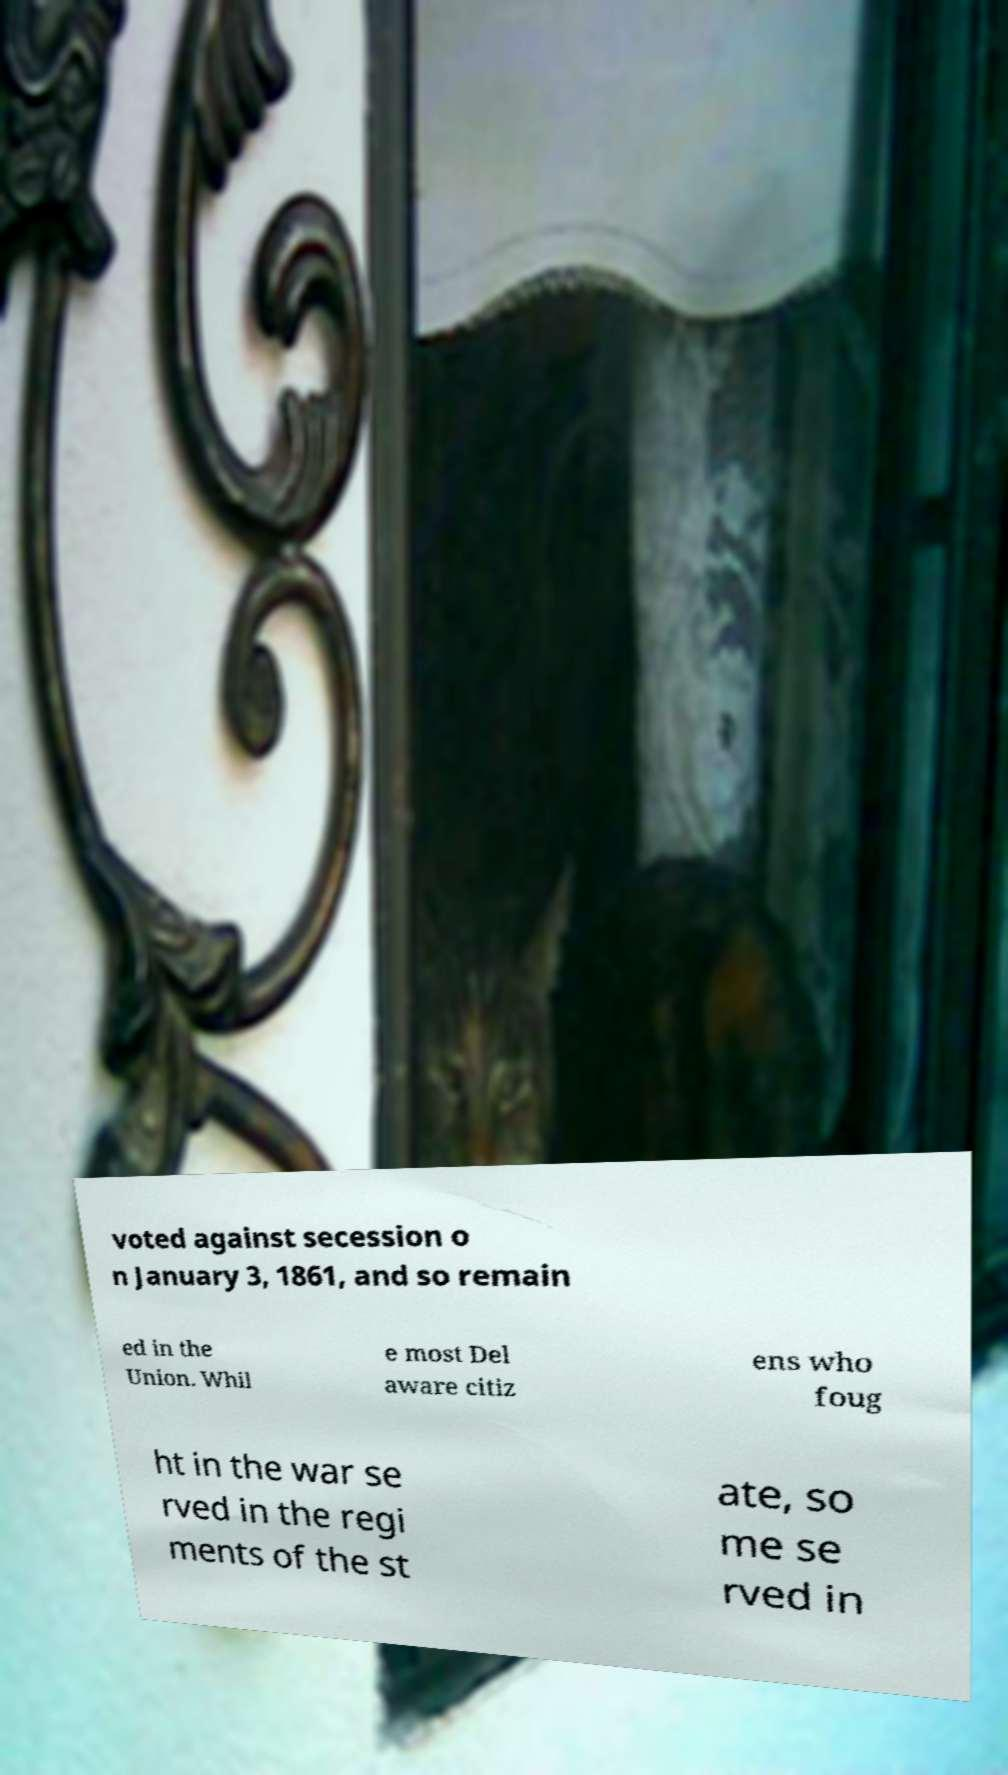Could you extract and type out the text from this image? voted against secession o n January 3, 1861, and so remain ed in the Union. Whil e most Del aware citiz ens who foug ht in the war se rved in the regi ments of the st ate, so me se rved in 